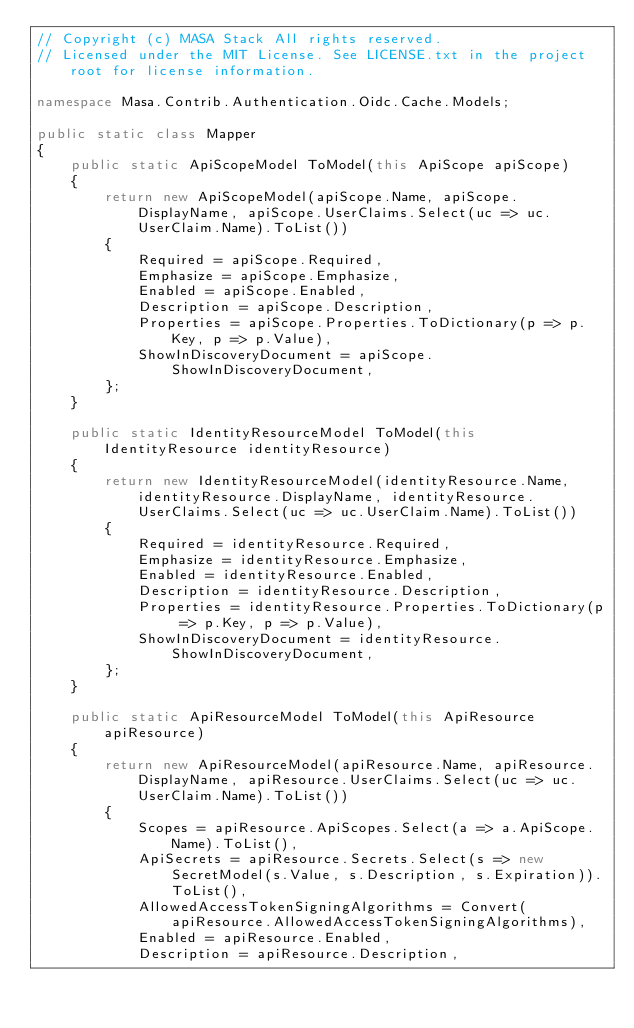<code> <loc_0><loc_0><loc_500><loc_500><_C#_>// Copyright (c) MASA Stack All rights reserved.
// Licensed under the MIT License. See LICENSE.txt in the project root for license information.

namespace Masa.Contrib.Authentication.Oidc.Cache.Models;

public static class Mapper
{
    public static ApiScopeModel ToModel(this ApiScope apiScope)
    {
        return new ApiScopeModel(apiScope.Name, apiScope.DisplayName, apiScope.UserClaims.Select(uc => uc.UserClaim.Name).ToList())
        {
            Required = apiScope.Required,
            Emphasize = apiScope.Emphasize,
            Enabled = apiScope.Enabled,
            Description = apiScope.Description,
            Properties = apiScope.Properties.ToDictionary(p => p.Key, p => p.Value),
            ShowInDiscoveryDocument = apiScope.ShowInDiscoveryDocument,
        };
    }

    public static IdentityResourceModel ToModel(this IdentityResource identityResource)
    {
        return new IdentityResourceModel(identityResource.Name, identityResource.DisplayName, identityResource.UserClaims.Select(uc => uc.UserClaim.Name).ToList())
        {
            Required = identityResource.Required,
            Emphasize = identityResource.Emphasize,
            Enabled = identityResource.Enabled,
            Description = identityResource.Description,
            Properties = identityResource.Properties.ToDictionary(p => p.Key, p => p.Value),
            ShowInDiscoveryDocument = identityResource.ShowInDiscoveryDocument,
        };
    }

    public static ApiResourceModel ToModel(this ApiResource apiResource)
    {
        return new ApiResourceModel(apiResource.Name, apiResource.DisplayName, apiResource.UserClaims.Select(uc => uc.UserClaim.Name).ToList())
        {
            Scopes = apiResource.ApiScopes.Select(a => a.ApiScope.Name).ToList(),
            ApiSecrets = apiResource.Secrets.Select(s => new SecretModel(s.Value, s.Description, s.Expiration)).ToList(),
            AllowedAccessTokenSigningAlgorithms = Convert(apiResource.AllowedAccessTokenSigningAlgorithms),
            Enabled = apiResource.Enabled,
            Description = apiResource.Description,</code> 